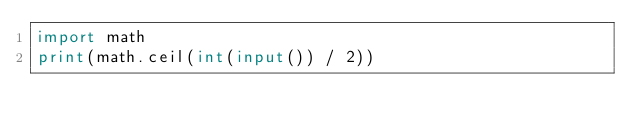Convert code to text. <code><loc_0><loc_0><loc_500><loc_500><_Python_>import math
print(math.ceil(int(input()) / 2))</code> 